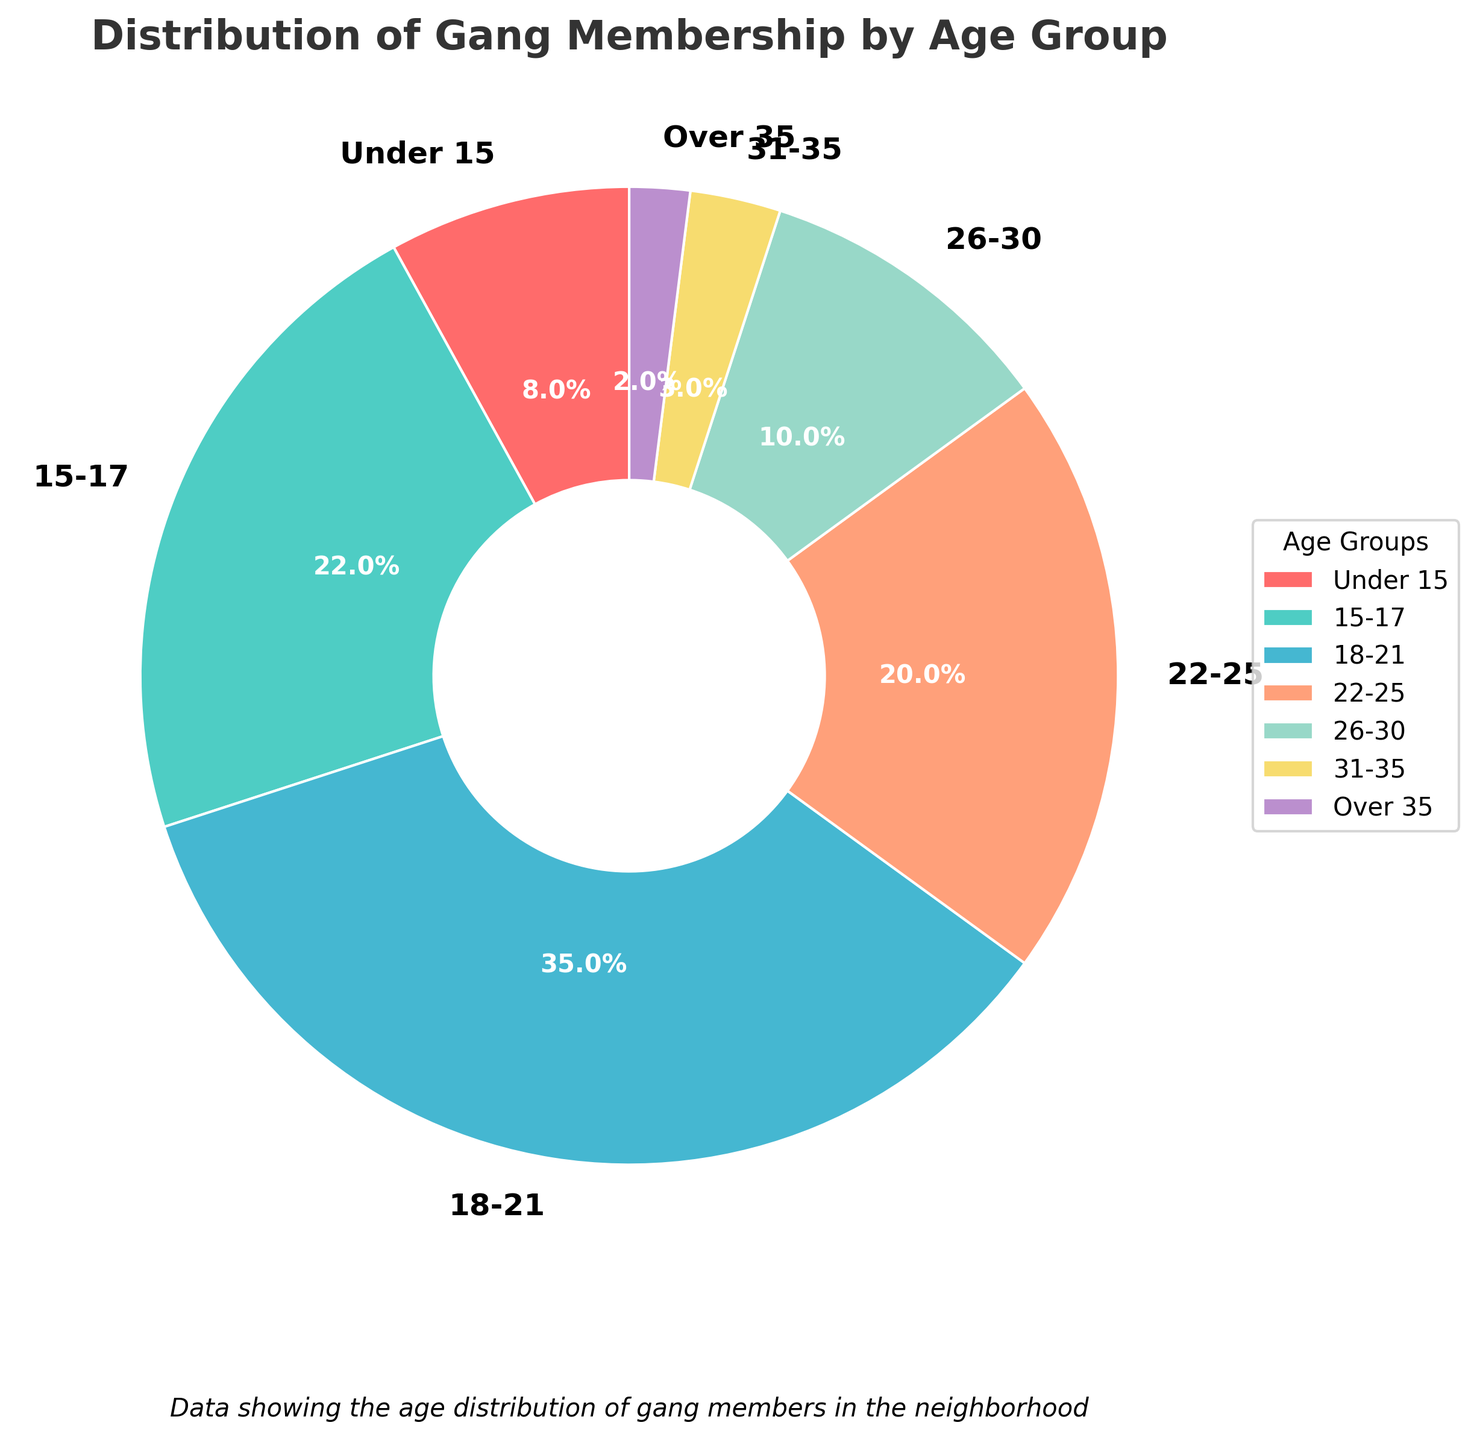What age group has the highest percentage of gang membership? The age group with the highest percentage of gang membership is represented by the largest wedge in the pie chart. In this chart, the "18-21" age group has the largest wedge.
Answer: 18-21 Which two age groups together account for more than half of the gang membership? To determine this, we need to find two age groups whose percentages add up to more than 50%. The "18-21" age group has 35% and the "15-17" age group has 22%. Together, they account for 35% + 22% = 57%, which is more than half.
Answer: 18-21 and 15-17 What is the combined percentage of gang members who are 25 years old or younger? To find this, we sum the percentages of all age groups 25 years old or younger: "Under 15" (8%), "15-17" (22%), "18-21" (35%), and "22-25" (20%). The total is 8% + 22% + 35% + 20% = 85%.
Answer: 85% Is the percentage of gang members over 30 years old greater than those under 15 years? To compare, we look at the percentages: Age groups "31-35" (3%) and "Over 35" (2%) together make 5%, while the "Under 15" group has 8%. So, 5% is less than 8%.
Answer: No Which age group has a percentage similar to the age group "22-25"? To find this, we look for an age group with a percentage close to the 20% of the "22-25" group. The nearest is "26-30", which has 10%.
Answer: 26-30 What is the difference in gang membership percentage between the 18-21 and 22-25 age groups? To find this difference, subtract the percentage of "22-25" (20%) from "18-21" (35%): 35% - 20% = 15%.
Answer: 15% How does the percentage of gang members in the "Under 15" age group compare to the "31-35" and "Over 35" groups combined? Add together "31-35" (3%) and "Over 35" (2%) to get 5%. The "Under 15" age group has 8%, which is greater than 5%.
Answer: Greater Which age group represents the second-largest slice in the pie chart? The second-largest slice after "18-21" (35%) is "15-17" (22%).
Answer: 15-17 What is the total percentage of gang members in the age groups "26-30" and above? Sum the percentages for "26-30" (10%), "31-35" (3%), and "Over 35" (2%): 10% + 3% + 2% = 15%.
Answer: 15% Which age group is represented by the blue color in the pie chart? Identify the color of the wedge representing each age group. The "18-21" age group is shown in blue.
Answer: 18-21 